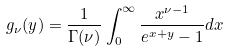Convert formula to latex. <formula><loc_0><loc_0><loc_500><loc_500>g _ { \nu } ( y ) = \frac { 1 } { \Gamma ( \nu ) } \int _ { 0 } ^ { \infty } \frac { x ^ { \nu - 1 } } { e ^ { x + y } - 1 } d x</formula> 